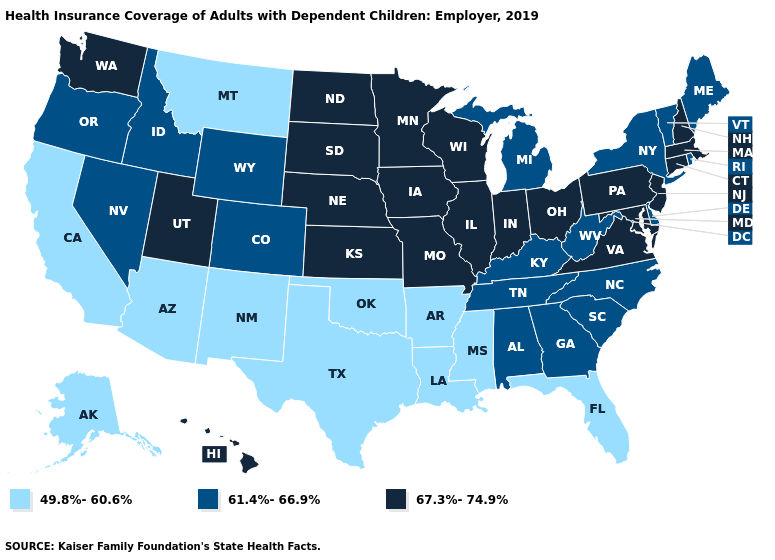Does New York have the highest value in the Northeast?
Give a very brief answer. No. Name the states that have a value in the range 61.4%-66.9%?
Answer briefly. Alabama, Colorado, Delaware, Georgia, Idaho, Kentucky, Maine, Michigan, Nevada, New York, North Carolina, Oregon, Rhode Island, South Carolina, Tennessee, Vermont, West Virginia, Wyoming. Does Texas have a lower value than Wisconsin?
Short answer required. Yes. What is the value of South Dakota?
Be succinct. 67.3%-74.9%. Does Louisiana have the same value as Mississippi?
Answer briefly. Yes. Name the states that have a value in the range 49.8%-60.6%?
Write a very short answer. Alaska, Arizona, Arkansas, California, Florida, Louisiana, Mississippi, Montana, New Mexico, Oklahoma, Texas. What is the value of Kentucky?
Short answer required. 61.4%-66.9%. Name the states that have a value in the range 67.3%-74.9%?
Write a very short answer. Connecticut, Hawaii, Illinois, Indiana, Iowa, Kansas, Maryland, Massachusetts, Minnesota, Missouri, Nebraska, New Hampshire, New Jersey, North Dakota, Ohio, Pennsylvania, South Dakota, Utah, Virginia, Washington, Wisconsin. What is the value of New York?
Give a very brief answer. 61.4%-66.9%. What is the lowest value in the West?
Concise answer only. 49.8%-60.6%. Which states have the highest value in the USA?
Quick response, please. Connecticut, Hawaii, Illinois, Indiana, Iowa, Kansas, Maryland, Massachusetts, Minnesota, Missouri, Nebraska, New Hampshire, New Jersey, North Dakota, Ohio, Pennsylvania, South Dakota, Utah, Virginia, Washington, Wisconsin. Is the legend a continuous bar?
Answer briefly. No. Name the states that have a value in the range 67.3%-74.9%?
Answer briefly. Connecticut, Hawaii, Illinois, Indiana, Iowa, Kansas, Maryland, Massachusetts, Minnesota, Missouri, Nebraska, New Hampshire, New Jersey, North Dakota, Ohio, Pennsylvania, South Dakota, Utah, Virginia, Washington, Wisconsin. What is the value of New Hampshire?
Quick response, please. 67.3%-74.9%. What is the value of Tennessee?
Short answer required. 61.4%-66.9%. 